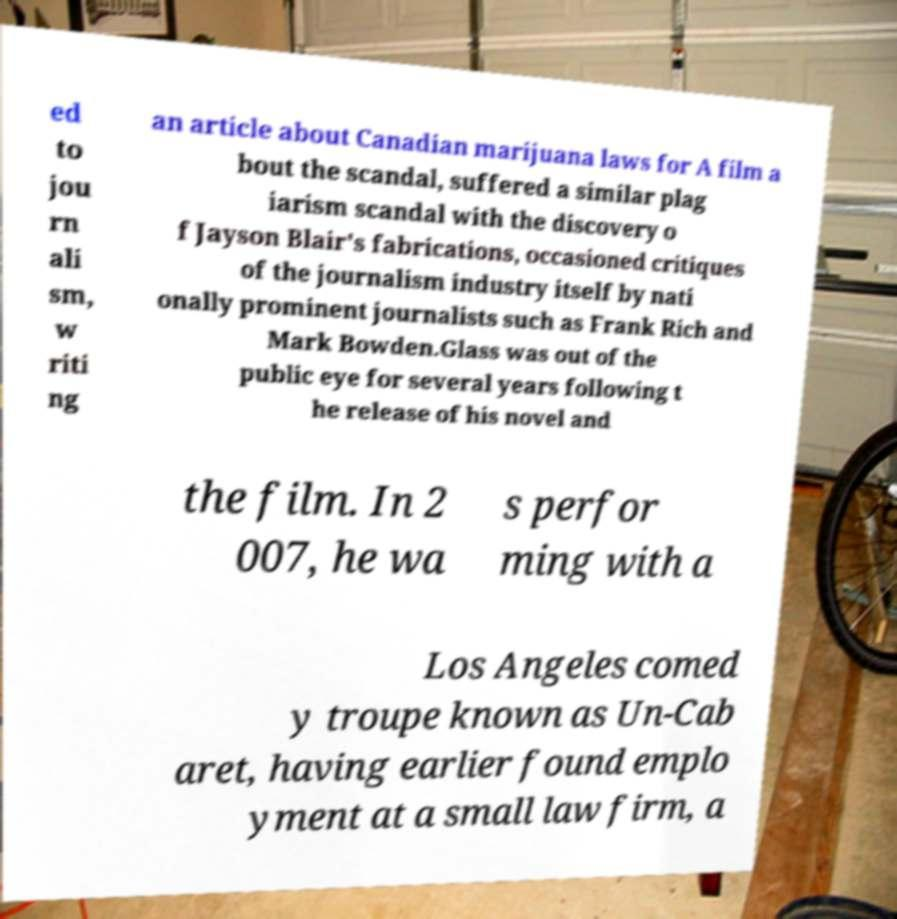Please read and relay the text visible in this image. What does it say? ed to jou rn ali sm, w riti ng an article about Canadian marijuana laws for A film a bout the scandal, suffered a similar plag iarism scandal with the discovery o f Jayson Blair's fabrications, occasioned critiques of the journalism industry itself by nati onally prominent journalists such as Frank Rich and Mark Bowden.Glass was out of the public eye for several years following t he release of his novel and the film. In 2 007, he wa s perfor ming with a Los Angeles comed y troupe known as Un-Cab aret, having earlier found emplo yment at a small law firm, a 